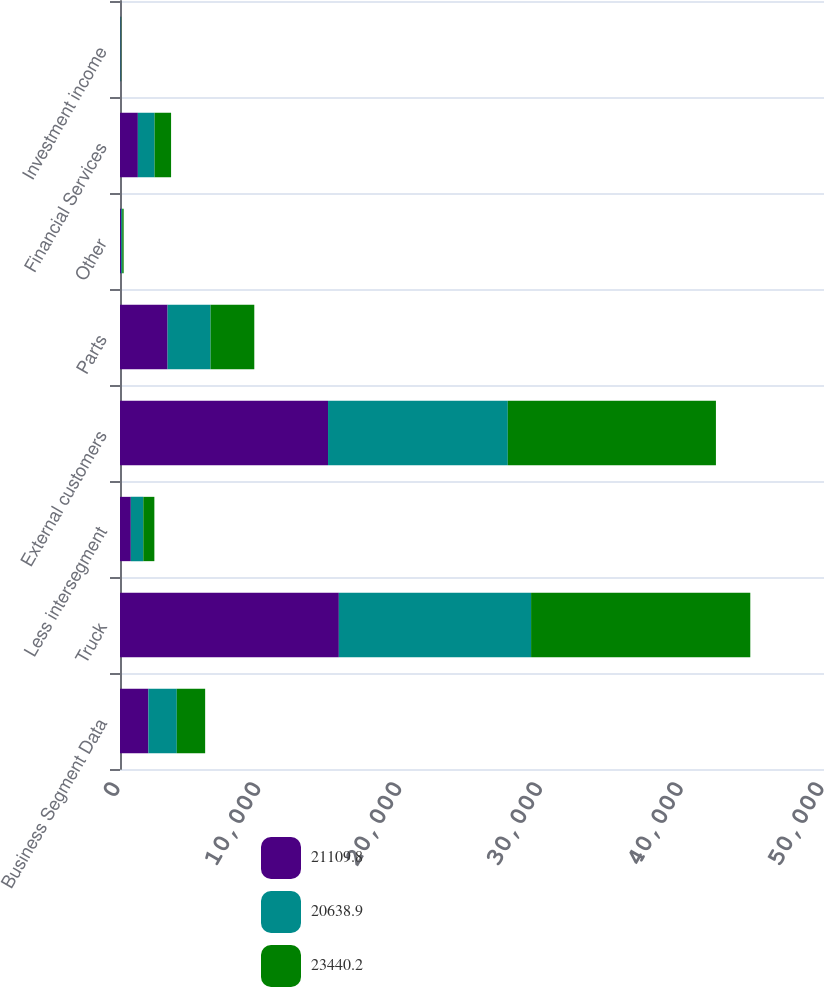<chart> <loc_0><loc_0><loc_500><loc_500><stacked_bar_chart><ecel><fcel>Business Segment Data<fcel>Truck<fcel>Less intersegment<fcel>External customers<fcel>Parts<fcel>Other<fcel>Financial Services<fcel>Investment income<nl><fcel>21109.8<fcel>2017<fcel>15543.7<fcel>768.9<fcel>14774.8<fcel>3380.2<fcel>85.7<fcel>1268.9<fcel>35.3<nl><fcel>20638.9<fcel>2016<fcel>13652.7<fcel>885.4<fcel>12767.3<fcel>3052.9<fcel>73.6<fcel>1186.7<fcel>27.6<nl><fcel>23440.2<fcel>2015<fcel>15568.6<fcel>786.1<fcel>14782.5<fcel>3104.7<fcel>100.2<fcel>1172.3<fcel>21.8<nl></chart> 